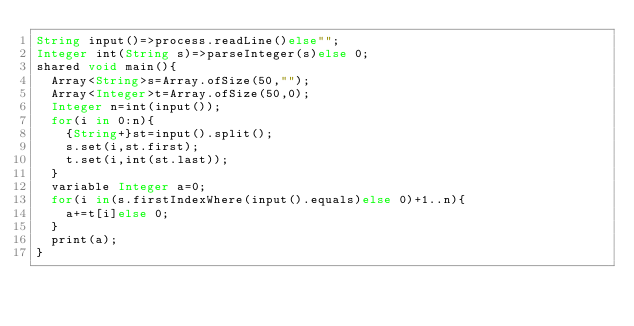<code> <loc_0><loc_0><loc_500><loc_500><_Ceylon_>String input()=>process.readLine()else""; 
Integer int(String s)=>parseInteger(s)else 0;
shared void main(){
  Array<String>s=Array.ofSize(50,"");
  Array<Integer>t=Array.ofSize(50,0);
  Integer n=int(input());
  for(i in 0:n){
    {String+}st=input().split();
    s.set(i,st.first);
    t.set(i,int(st.last));
  }
  variable Integer a=0;
  for(i in(s.firstIndexWhere(input().equals)else 0)+1..n){
    a+=t[i]else 0;
  }
  print(a);
}
</code> 